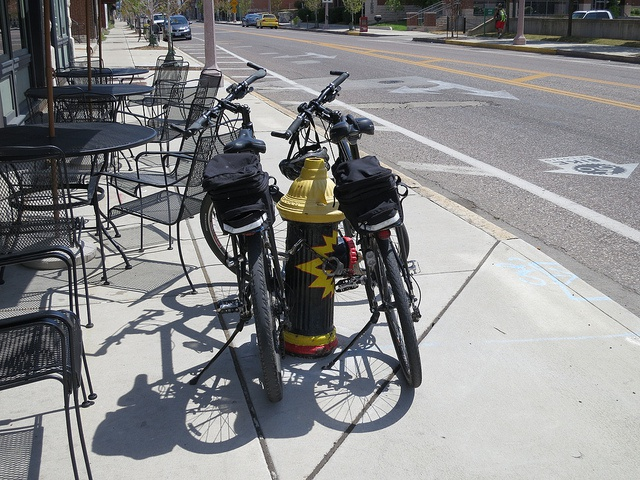Describe the objects in this image and their specific colors. I can see bicycle in black, gray, darkgray, and lightgray tones, bicycle in black, gray, lightgray, and darkgray tones, fire hydrant in black, olive, gray, and maroon tones, chair in black, gray, darkgray, and lightgray tones, and chair in black, gray, and darkgray tones in this image. 